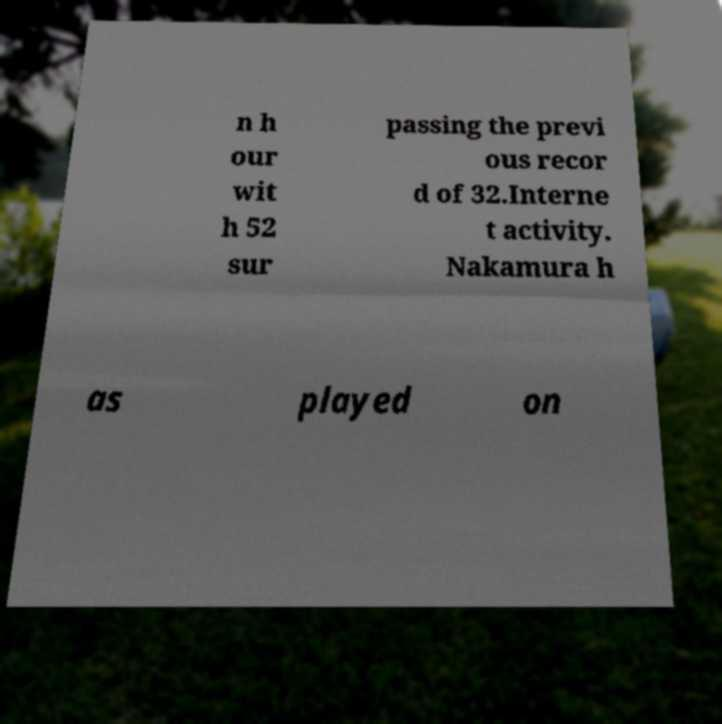Can you read and provide the text displayed in the image?This photo seems to have some interesting text. Can you extract and type it out for me? n h our wit h 52 sur passing the previ ous recor d of 32.Interne t activity. Nakamura h as played on 